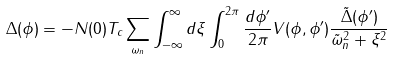<formula> <loc_0><loc_0><loc_500><loc_500>\Delta ( \phi ) = - N ( 0 ) T _ { c } \sum _ { \omega _ { n } } \int _ { - \infty } ^ { \infty } d { \xi } \int _ { 0 } ^ { 2 \pi } \frac { d { \phi ^ { \prime } } } { 2 \pi } V ( \phi , \phi ^ { \prime } ) \frac { \tilde { \Delta } ( \phi ^ { \prime } ) } { \tilde { \omega } _ { n } ^ { 2 } + \xi ^ { 2 } }</formula> 